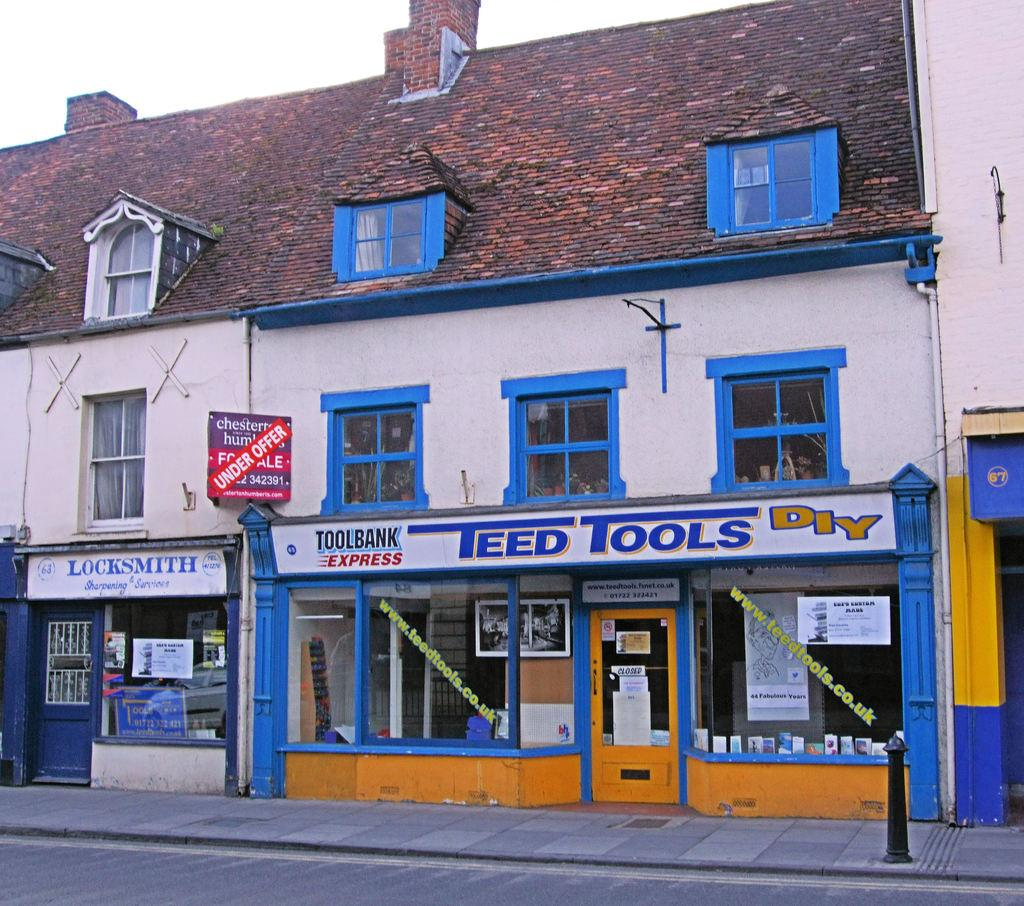What is the main subject of the image? The main subject of the image is a building. What can be seen on the building? There are boards with text on the building. What architectural feature is present on the building? The building has windows. What objects are visible in the image? There are glasses visible in the image. Can you tell me how many chickens are jumping in the image? There are no chickens or jumping depicted in the image; it features a building with boards and windows, and glasses. 